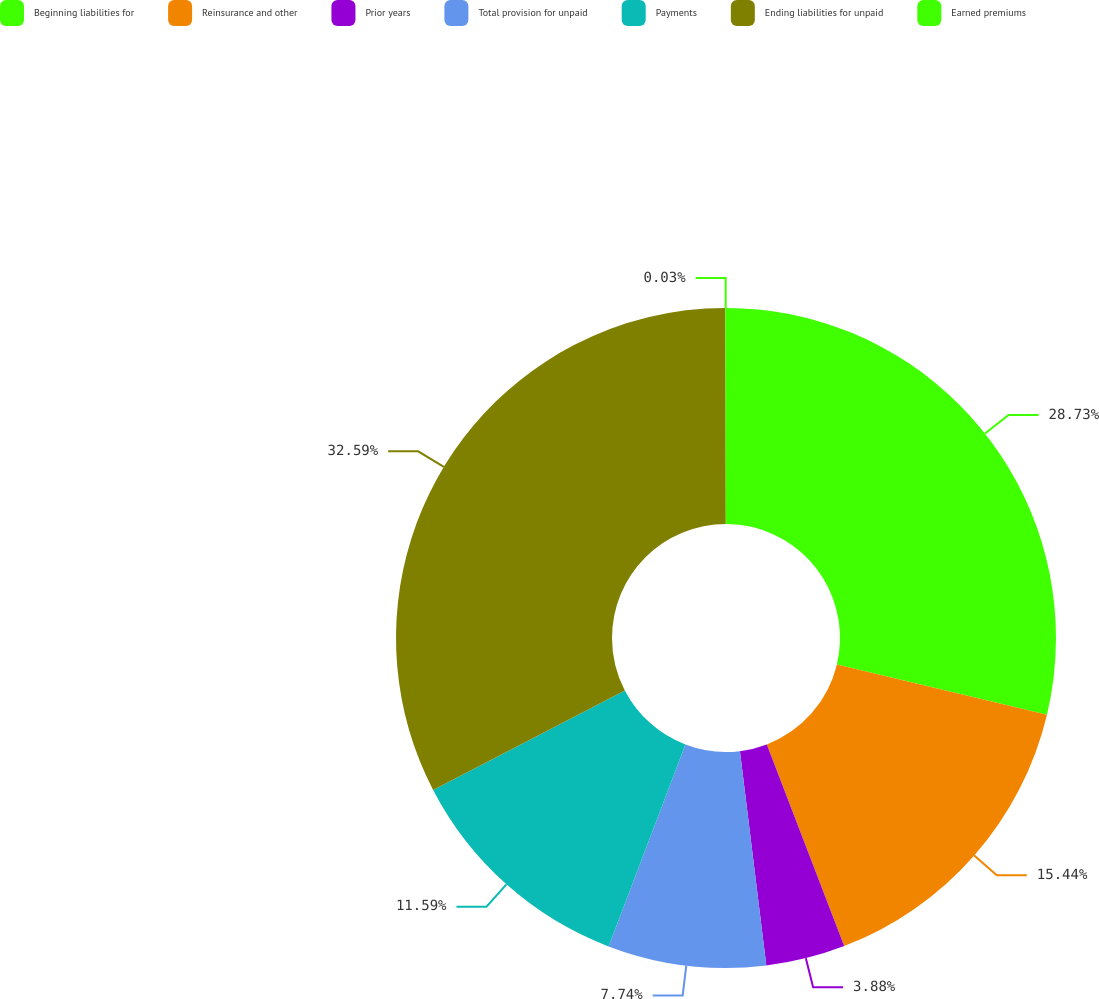<chart> <loc_0><loc_0><loc_500><loc_500><pie_chart><fcel>Beginning liabilities for<fcel>Reinsurance and other<fcel>Prior years<fcel>Total provision for unpaid<fcel>Payments<fcel>Ending liabilities for unpaid<fcel>Earned premiums<nl><fcel>28.73%<fcel>15.44%<fcel>3.88%<fcel>7.74%<fcel>11.59%<fcel>32.59%<fcel>0.03%<nl></chart> 